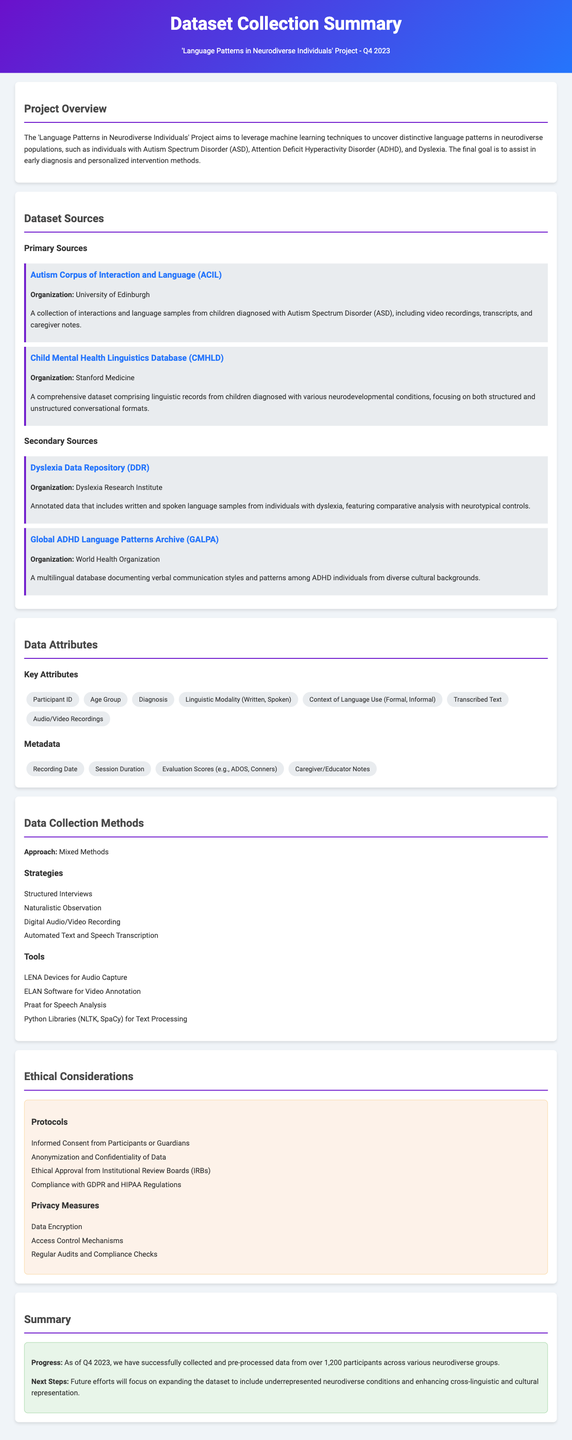what is the title of the project? The title of the project is provided in the header of the document.
Answer: Language Patterns in Neurodiverse Individuals who is the organization behind the Autism Corpus of Interaction and Language? The organization responsible for this dataset is listed under the dataset sources section.
Answer: University of Edinburgh how many participants' data has been collected as of Q4 2023? The document specifies the number of participants in the summary section.
Answer: over 1,200 which tool is used for speech analysis? The tool used for speech analysis is mentioned in the tools list under data collection methods.
Answer: Praat what is one ethical protocol mentioned for data collection? The document lists several ethical protocols under the ethical considerations section.
Answer: Informed Consent from Participants or Guardians which organization provides the Global ADHD Language Patterns Archive? The organization that provides this archive is mentioned in the secondary sources section.
Answer: World Health Organization what approach is used for data collection? The approach used for data collection is described in the data collection methods section.
Answer: Mixed Methods what is one of the key attributes of the dataset? Several key attributes are listed in the data attributes section.
Answer: Participant ID 